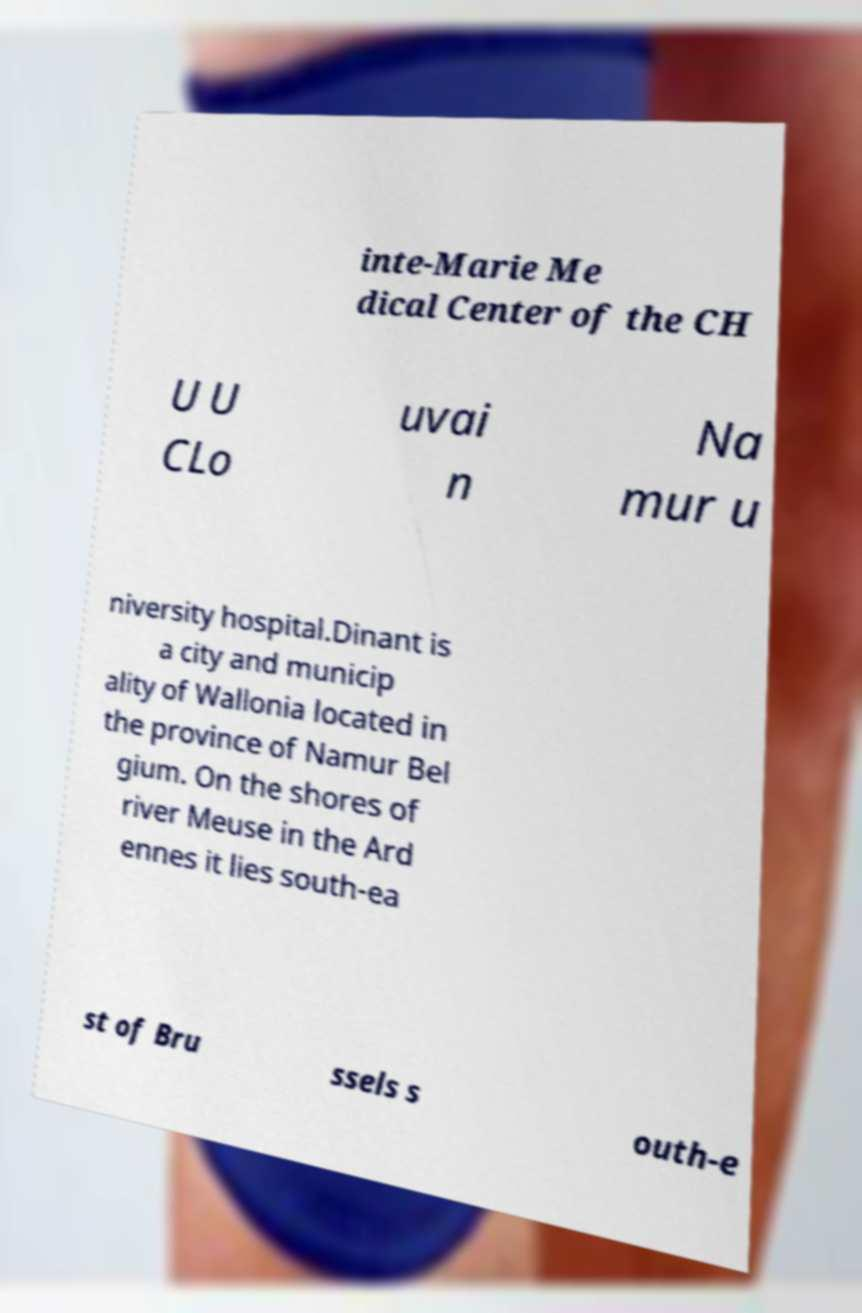Please identify and transcribe the text found in this image. inte-Marie Me dical Center of the CH U U CLo uvai n Na mur u niversity hospital.Dinant is a city and municip ality of Wallonia located in the province of Namur Bel gium. On the shores of river Meuse in the Ard ennes it lies south-ea st of Bru ssels s outh-e 